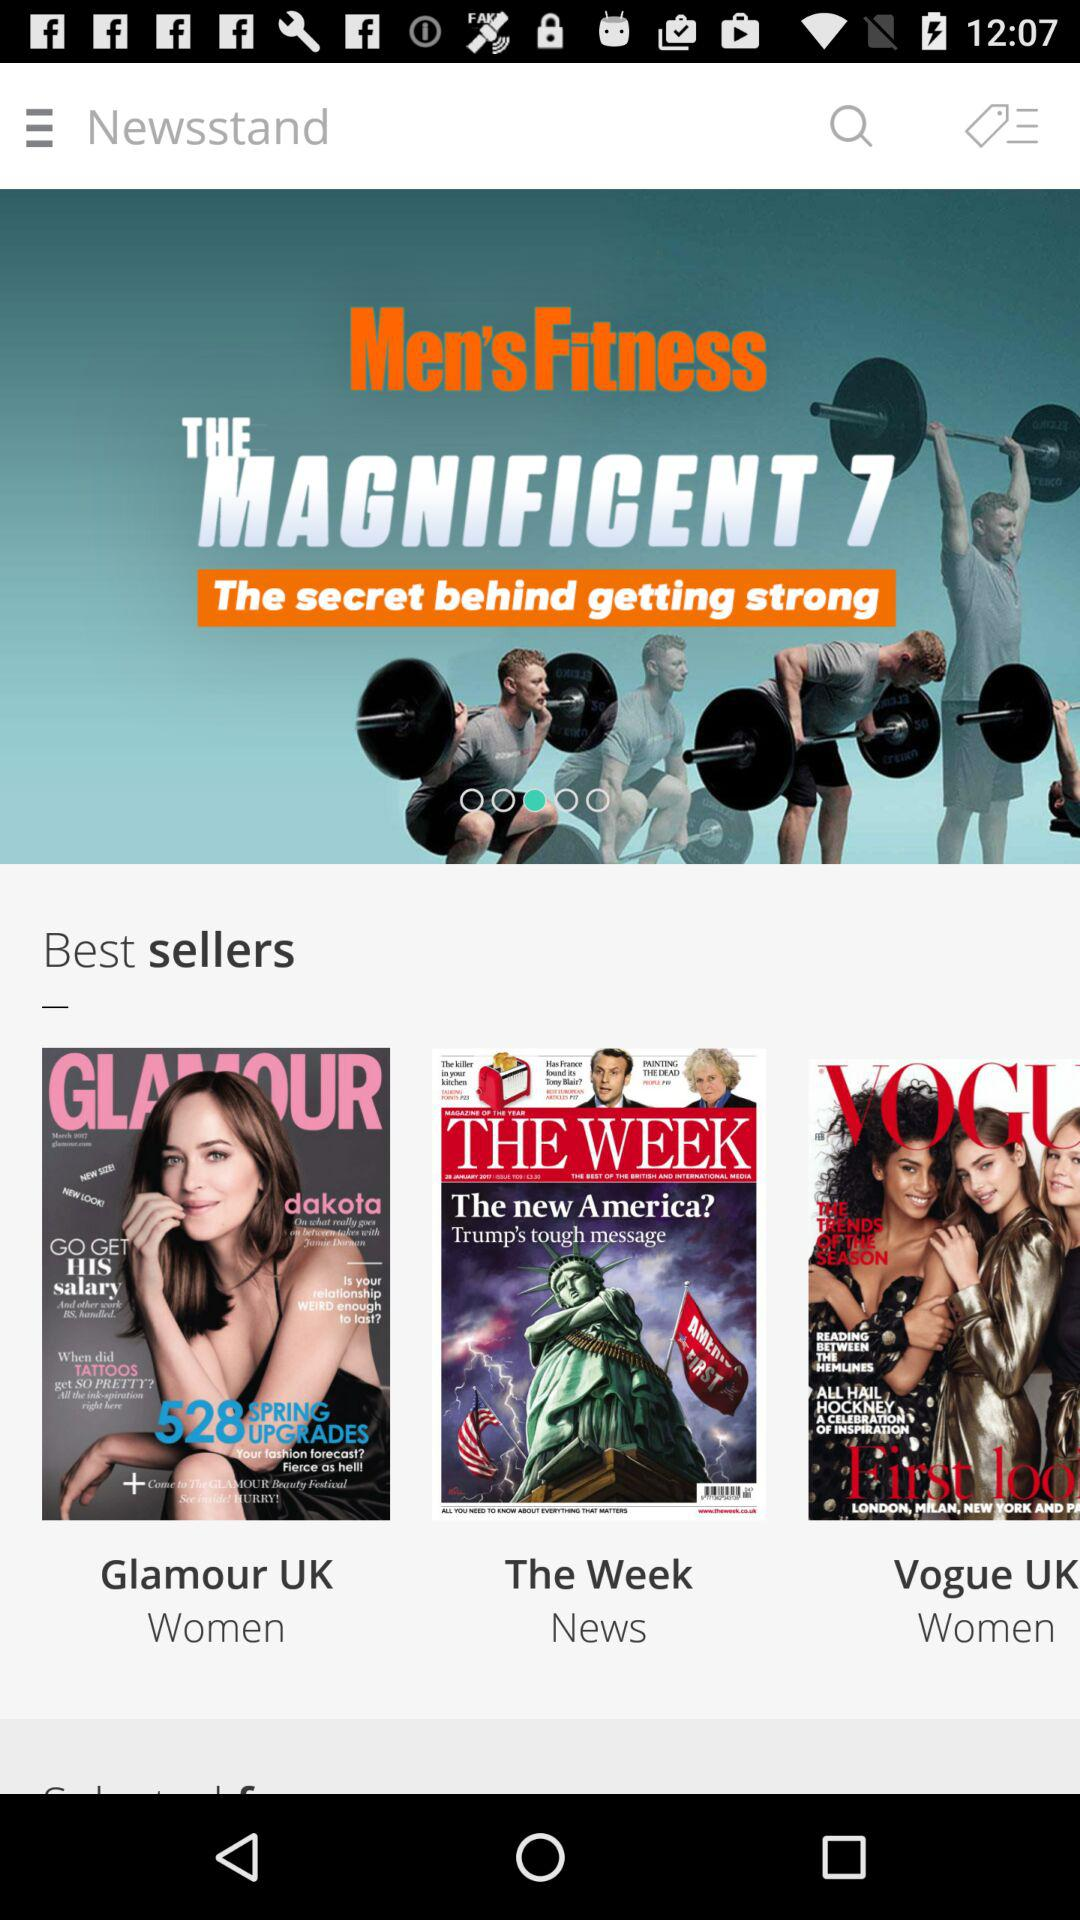What are the mastheads of the magazines? The mastheads of the magazines are "Glamour UK", "The Week" and "Vogue UK". 